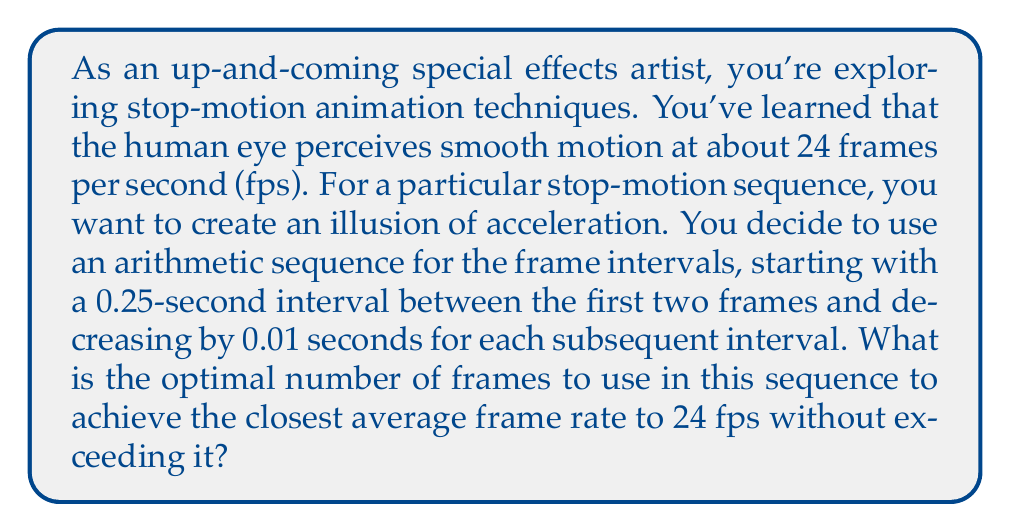Could you help me with this problem? Let's approach this step-by-step:

1) First, we need to set up our arithmetic sequence for the frame intervals:
   $a_1 = 0.25$ seconds (first interval)
   $d = -0.01$ seconds (common difference)
   $a_n = a_1 + (n-1)d$ (general term of arithmetic sequence)

2) The sum of the first n terms of an arithmetic sequence is given by:
   $$S_n = \frac{n}{2}(a_1 + a_n)$$

3) We need to find $a_n$ in terms of n:
   $a_n = 0.25 + (n-1)(-0.01) = 0.26 - 0.01n$

4) Now we can express the total time for n frames:
   $$S_n = \frac{n}{2}(0.25 + (0.26 - 0.01n)) = \frac{n}{2}(0.51 - 0.01n) = 0.255n - 0.005n^2$$

5) To find the average frame rate, we divide the number of frames by the total time:
   $$\text{Average fps} = \frac{n}{S_n} = \frac{n}{0.255n - 0.005n^2}$$

6) We want this to be as close to 24 fps as possible without exceeding it:
   $$\frac{n}{0.255n - 0.005n^2} \leq 24$$

7) Solving this inequality:
   $n \leq 24(0.255n - 0.005n^2)$
   $n \leq 6.12n - 0.12n^2$
   $0.12n^2 - 5.12n + 1 \geq 0$

8) This is a quadratic inequality. Solving it, we get:
   $1 \leq n \leq 42.33$

9) Since n must be a whole number, the largest value it can take is 42.

10) We can verify that for n = 42:
    Average fps = 42 / (0.255*42 - 0.005*42^2) ≈ 23.98 fps

11) For n = 43:
    Average fps = 43 / (0.255*43 - 0.005*43^2) ≈ 24.13 fps, which exceeds 24 fps.

Therefore, the optimal number of frames is 42.
Answer: 42 frames 